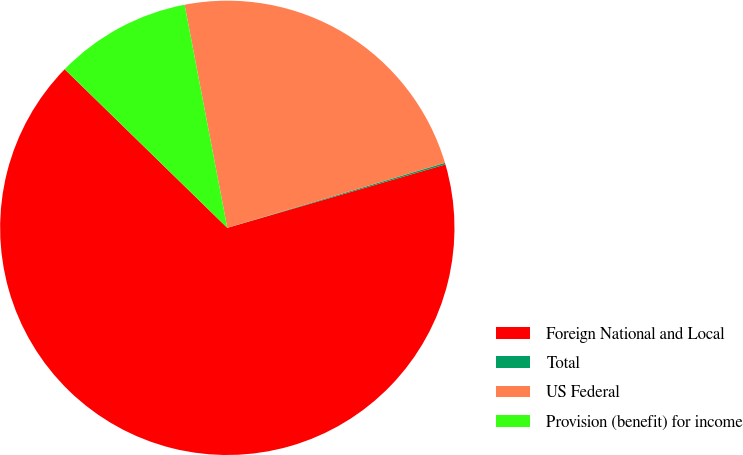Convert chart to OTSL. <chart><loc_0><loc_0><loc_500><loc_500><pie_chart><fcel>Foreign National and Local<fcel>Total<fcel>US Federal<fcel>Provision (benefit) for income<nl><fcel>66.81%<fcel>0.12%<fcel>23.39%<fcel>9.69%<nl></chart> 